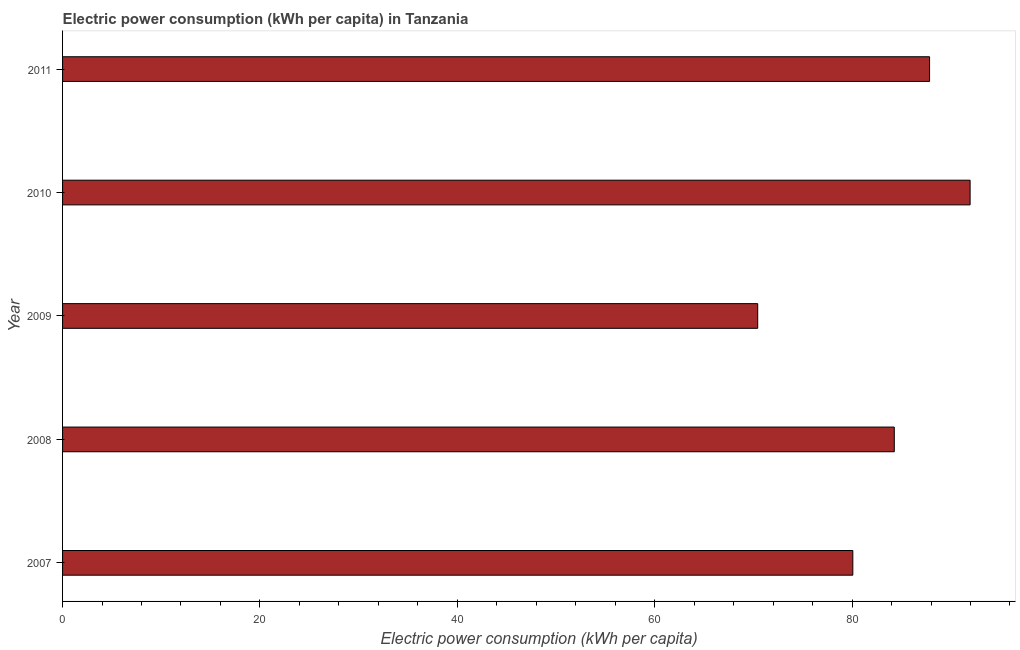Does the graph contain any zero values?
Your answer should be very brief. No. Does the graph contain grids?
Offer a terse response. No. What is the title of the graph?
Provide a succinct answer. Electric power consumption (kWh per capita) in Tanzania. What is the label or title of the X-axis?
Make the answer very short. Electric power consumption (kWh per capita). What is the label or title of the Y-axis?
Offer a very short reply. Year. What is the electric power consumption in 2008?
Your answer should be compact. 84.28. Across all years, what is the maximum electric power consumption?
Make the answer very short. 91.96. Across all years, what is the minimum electric power consumption?
Ensure brevity in your answer.  70.44. In which year was the electric power consumption maximum?
Your answer should be very brief. 2010. In which year was the electric power consumption minimum?
Make the answer very short. 2009. What is the sum of the electric power consumption?
Offer a terse response. 414.62. What is the difference between the electric power consumption in 2008 and 2011?
Your answer should be compact. -3.57. What is the average electric power consumption per year?
Keep it short and to the point. 82.92. What is the median electric power consumption?
Offer a very short reply. 84.28. Do a majority of the years between 2009 and 2011 (inclusive) have electric power consumption greater than 32 kWh per capita?
Make the answer very short. Yes. What is the ratio of the electric power consumption in 2010 to that in 2011?
Give a very brief answer. 1.05. Is the difference between the electric power consumption in 2007 and 2008 greater than the difference between any two years?
Offer a very short reply. No. What is the difference between the highest and the second highest electric power consumption?
Your answer should be very brief. 4.11. Is the sum of the electric power consumption in 2008 and 2009 greater than the maximum electric power consumption across all years?
Your answer should be very brief. Yes. What is the difference between the highest and the lowest electric power consumption?
Provide a short and direct response. 21.52. How many bars are there?
Ensure brevity in your answer.  5. Are all the bars in the graph horizontal?
Your response must be concise. Yes. How many years are there in the graph?
Provide a short and direct response. 5. Are the values on the major ticks of X-axis written in scientific E-notation?
Your answer should be very brief. No. What is the Electric power consumption (kWh per capita) in 2007?
Ensure brevity in your answer.  80.08. What is the Electric power consumption (kWh per capita) in 2008?
Provide a short and direct response. 84.28. What is the Electric power consumption (kWh per capita) of 2009?
Offer a very short reply. 70.44. What is the Electric power consumption (kWh per capita) of 2010?
Provide a short and direct response. 91.96. What is the Electric power consumption (kWh per capita) of 2011?
Provide a succinct answer. 87.86. What is the difference between the Electric power consumption (kWh per capita) in 2007 and 2008?
Make the answer very short. -4.2. What is the difference between the Electric power consumption (kWh per capita) in 2007 and 2009?
Offer a terse response. 9.64. What is the difference between the Electric power consumption (kWh per capita) in 2007 and 2010?
Give a very brief answer. -11.89. What is the difference between the Electric power consumption (kWh per capita) in 2007 and 2011?
Your answer should be very brief. -7.78. What is the difference between the Electric power consumption (kWh per capita) in 2008 and 2009?
Give a very brief answer. 13.84. What is the difference between the Electric power consumption (kWh per capita) in 2008 and 2010?
Your answer should be very brief. -7.68. What is the difference between the Electric power consumption (kWh per capita) in 2008 and 2011?
Offer a terse response. -3.57. What is the difference between the Electric power consumption (kWh per capita) in 2009 and 2010?
Make the answer very short. -21.52. What is the difference between the Electric power consumption (kWh per capita) in 2009 and 2011?
Your answer should be compact. -17.42. What is the difference between the Electric power consumption (kWh per capita) in 2010 and 2011?
Keep it short and to the point. 4.11. What is the ratio of the Electric power consumption (kWh per capita) in 2007 to that in 2009?
Offer a very short reply. 1.14. What is the ratio of the Electric power consumption (kWh per capita) in 2007 to that in 2010?
Your response must be concise. 0.87. What is the ratio of the Electric power consumption (kWh per capita) in 2007 to that in 2011?
Offer a very short reply. 0.91. What is the ratio of the Electric power consumption (kWh per capita) in 2008 to that in 2009?
Offer a terse response. 1.2. What is the ratio of the Electric power consumption (kWh per capita) in 2008 to that in 2010?
Your answer should be compact. 0.92. What is the ratio of the Electric power consumption (kWh per capita) in 2008 to that in 2011?
Ensure brevity in your answer.  0.96. What is the ratio of the Electric power consumption (kWh per capita) in 2009 to that in 2010?
Your answer should be compact. 0.77. What is the ratio of the Electric power consumption (kWh per capita) in 2009 to that in 2011?
Your response must be concise. 0.8. What is the ratio of the Electric power consumption (kWh per capita) in 2010 to that in 2011?
Offer a very short reply. 1.05. 